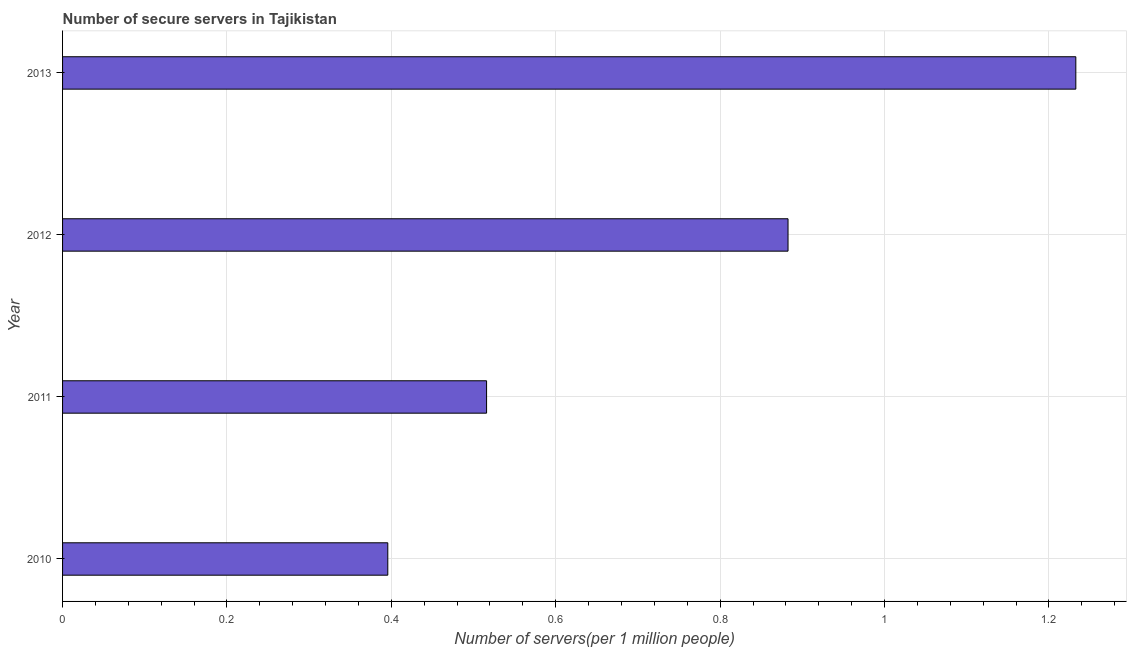Does the graph contain grids?
Keep it short and to the point. Yes. What is the title of the graph?
Your answer should be very brief. Number of secure servers in Tajikistan. What is the label or title of the X-axis?
Ensure brevity in your answer.  Number of servers(per 1 million people). What is the label or title of the Y-axis?
Your answer should be compact. Year. What is the number of secure internet servers in 2013?
Ensure brevity in your answer.  1.23. Across all years, what is the maximum number of secure internet servers?
Keep it short and to the point. 1.23. Across all years, what is the minimum number of secure internet servers?
Offer a very short reply. 0.4. In which year was the number of secure internet servers maximum?
Offer a very short reply. 2013. In which year was the number of secure internet servers minimum?
Provide a short and direct response. 2010. What is the sum of the number of secure internet servers?
Make the answer very short. 3.03. What is the difference between the number of secure internet servers in 2010 and 2013?
Offer a terse response. -0.84. What is the average number of secure internet servers per year?
Your answer should be very brief. 0.76. What is the median number of secure internet servers?
Provide a short and direct response. 0.7. In how many years, is the number of secure internet servers greater than 1.16 ?
Make the answer very short. 1. What is the ratio of the number of secure internet servers in 2010 to that in 2011?
Your answer should be compact. 0.77. Is the number of secure internet servers in 2010 less than that in 2012?
Provide a succinct answer. Yes. What is the difference between the highest and the lowest number of secure internet servers?
Offer a terse response. 0.84. In how many years, is the number of secure internet servers greater than the average number of secure internet servers taken over all years?
Your answer should be very brief. 2. How many bars are there?
Give a very brief answer. 4. Are all the bars in the graph horizontal?
Your answer should be very brief. Yes. How many years are there in the graph?
Offer a very short reply. 4. What is the Number of servers(per 1 million people) in 2010?
Your answer should be very brief. 0.4. What is the Number of servers(per 1 million people) of 2011?
Your answer should be very brief. 0.52. What is the Number of servers(per 1 million people) in 2012?
Your answer should be compact. 0.88. What is the Number of servers(per 1 million people) of 2013?
Provide a succinct answer. 1.23. What is the difference between the Number of servers(per 1 million people) in 2010 and 2011?
Offer a very short reply. -0.12. What is the difference between the Number of servers(per 1 million people) in 2010 and 2012?
Your answer should be very brief. -0.49. What is the difference between the Number of servers(per 1 million people) in 2010 and 2013?
Your answer should be compact. -0.84. What is the difference between the Number of servers(per 1 million people) in 2011 and 2012?
Offer a terse response. -0.37. What is the difference between the Number of servers(per 1 million people) in 2011 and 2013?
Your response must be concise. -0.72. What is the difference between the Number of servers(per 1 million people) in 2012 and 2013?
Make the answer very short. -0.35. What is the ratio of the Number of servers(per 1 million people) in 2010 to that in 2011?
Keep it short and to the point. 0.77. What is the ratio of the Number of servers(per 1 million people) in 2010 to that in 2012?
Give a very brief answer. 0.45. What is the ratio of the Number of servers(per 1 million people) in 2010 to that in 2013?
Provide a short and direct response. 0.32. What is the ratio of the Number of servers(per 1 million people) in 2011 to that in 2012?
Your response must be concise. 0.58. What is the ratio of the Number of servers(per 1 million people) in 2011 to that in 2013?
Offer a very short reply. 0.42. What is the ratio of the Number of servers(per 1 million people) in 2012 to that in 2013?
Ensure brevity in your answer.  0.72. 